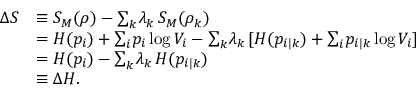<formula> <loc_0><loc_0><loc_500><loc_500>\begin{array} { r l } { \Delta S } & { \equiv S _ { M } ( \rho ) - { \sum } _ { k } \lambda _ { k } \, S _ { M } ( \rho _ { k } ) } \\ & { = H ( p _ { i } ) + { \sum } _ { i } p _ { i } \log V _ { i } - { \sum } _ { k } \lambda _ { k } \, [ H ( p _ { i | k } ) + { \sum } _ { i } p _ { i | k } \log V _ { i } ] } \\ & { = H ( p _ { i } ) - { \sum } _ { k } \lambda _ { k } \, H ( p _ { i | k } ) } \\ & { \equiv \Delta H . } \end{array}</formula> 